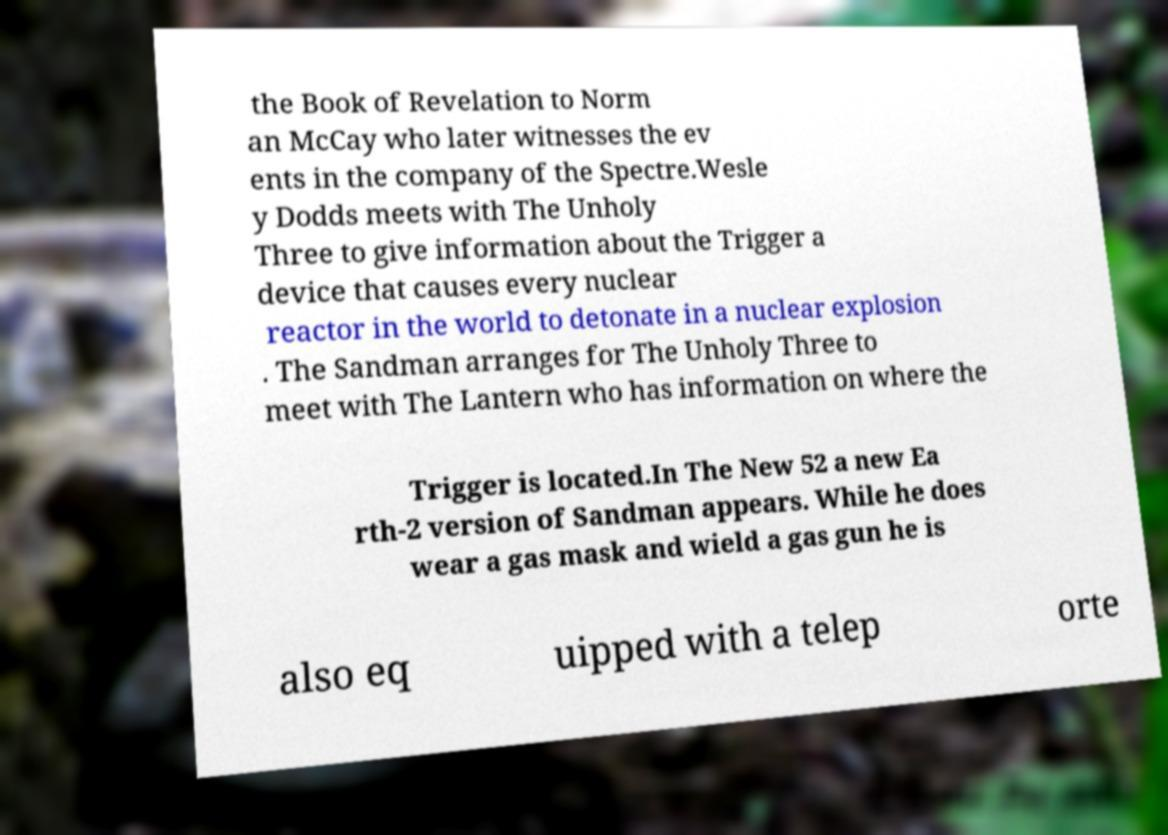Could you assist in decoding the text presented in this image and type it out clearly? the Book of Revelation to Norm an McCay who later witnesses the ev ents in the company of the Spectre.Wesle y Dodds meets with The Unholy Three to give information about the Trigger a device that causes every nuclear reactor in the world to detonate in a nuclear explosion . The Sandman arranges for The Unholy Three to meet with The Lantern who has information on where the Trigger is located.In The New 52 a new Ea rth-2 version of Sandman appears. While he does wear a gas mask and wield a gas gun he is also eq uipped with a telep orte 